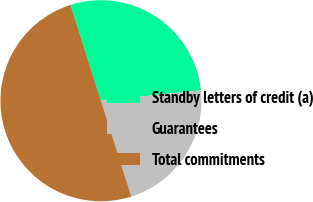<chart> <loc_0><loc_0><loc_500><loc_500><pie_chart><fcel>Standby letters of credit (a)<fcel>Guarantees<fcel>Total commitments<nl><fcel>28.24%<fcel>21.76%<fcel>50.0%<nl></chart> 